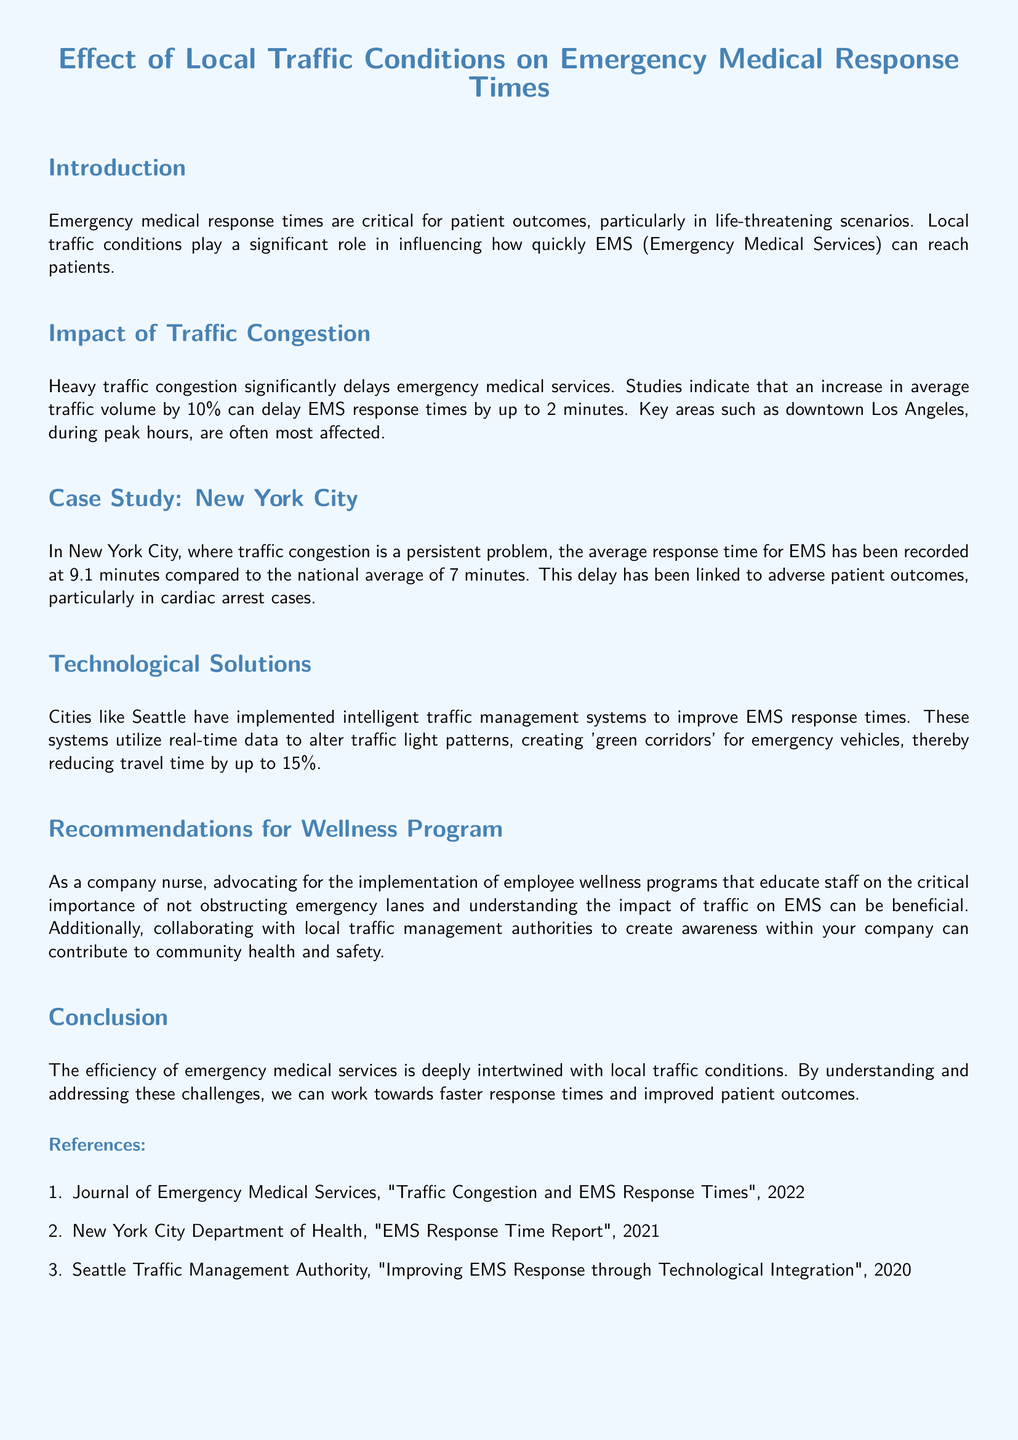What is the title of the report? The title of the report is explicitly stated at the beginning of the document.
Answer: Effect of Local Traffic Conditions on Emergency Medical Response Times What is the average EMS response time in New York City? The document provides specific data on EMS response times in New York City for comparison with the national average.
Answer: 9.1 minutes How much can a 10% increase in traffic volume delay EMS response times? The report includes statistics about the increase in response time associated with traffic volume changes.
Answer: 2 minutes What is the national average EMS response time? The document compares New York's EMS response time to the national average.
Answer: 7 minutes Which city has implemented intelligent traffic management systems? The report discusses technological solutions in specific cities and highlights one city's initiative.
Answer: Seattle What percentage reduction in travel time can intelligent traffic management systems achieve? The document mentions the effectiveness of these systems in terms of travel time reduction.
Answer: 15% What type of programs does the company nurse recommend? Recommendations for wellness programs are detailed, particularly emphasizing the importance of emergency lanes.
Answer: Employee wellness programs Which year was the "Traffic Congestion and EMS Response Times" study published? The report includes references with publication years for various studies.
Answer: 2022 What is one major impact of traffic congestion on EMS? The introduction discusses critical factors affecting emergency services, hinting at significant outcomes.
Answer: Delays 